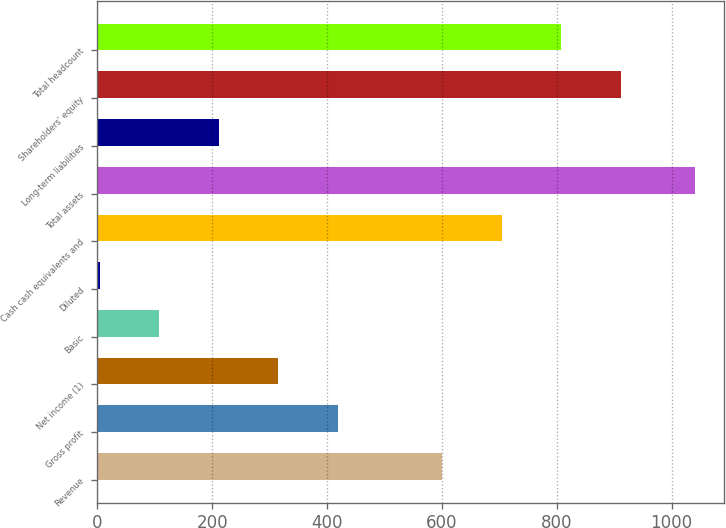Convert chart to OTSL. <chart><loc_0><loc_0><loc_500><loc_500><bar_chart><fcel>Revenue<fcel>Gross profit<fcel>Net income (1)<fcel>Basic<fcel>Diluted<fcel>Cash cash equivalents and<fcel>Total assets<fcel>Long-term liabilities<fcel>Shareholders' equity<fcel>Total headcount<nl><fcel>600.8<fcel>418.22<fcel>314.59<fcel>107.33<fcel>3.7<fcel>704.43<fcel>1040<fcel>210.96<fcel>911.69<fcel>808.06<nl></chart> 